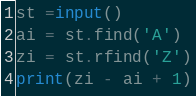<code> <loc_0><loc_0><loc_500><loc_500><_Python_>st =input()
ai = st.find('A')
zi = st.rfind('Z')
print(zi - ai + 1)</code> 